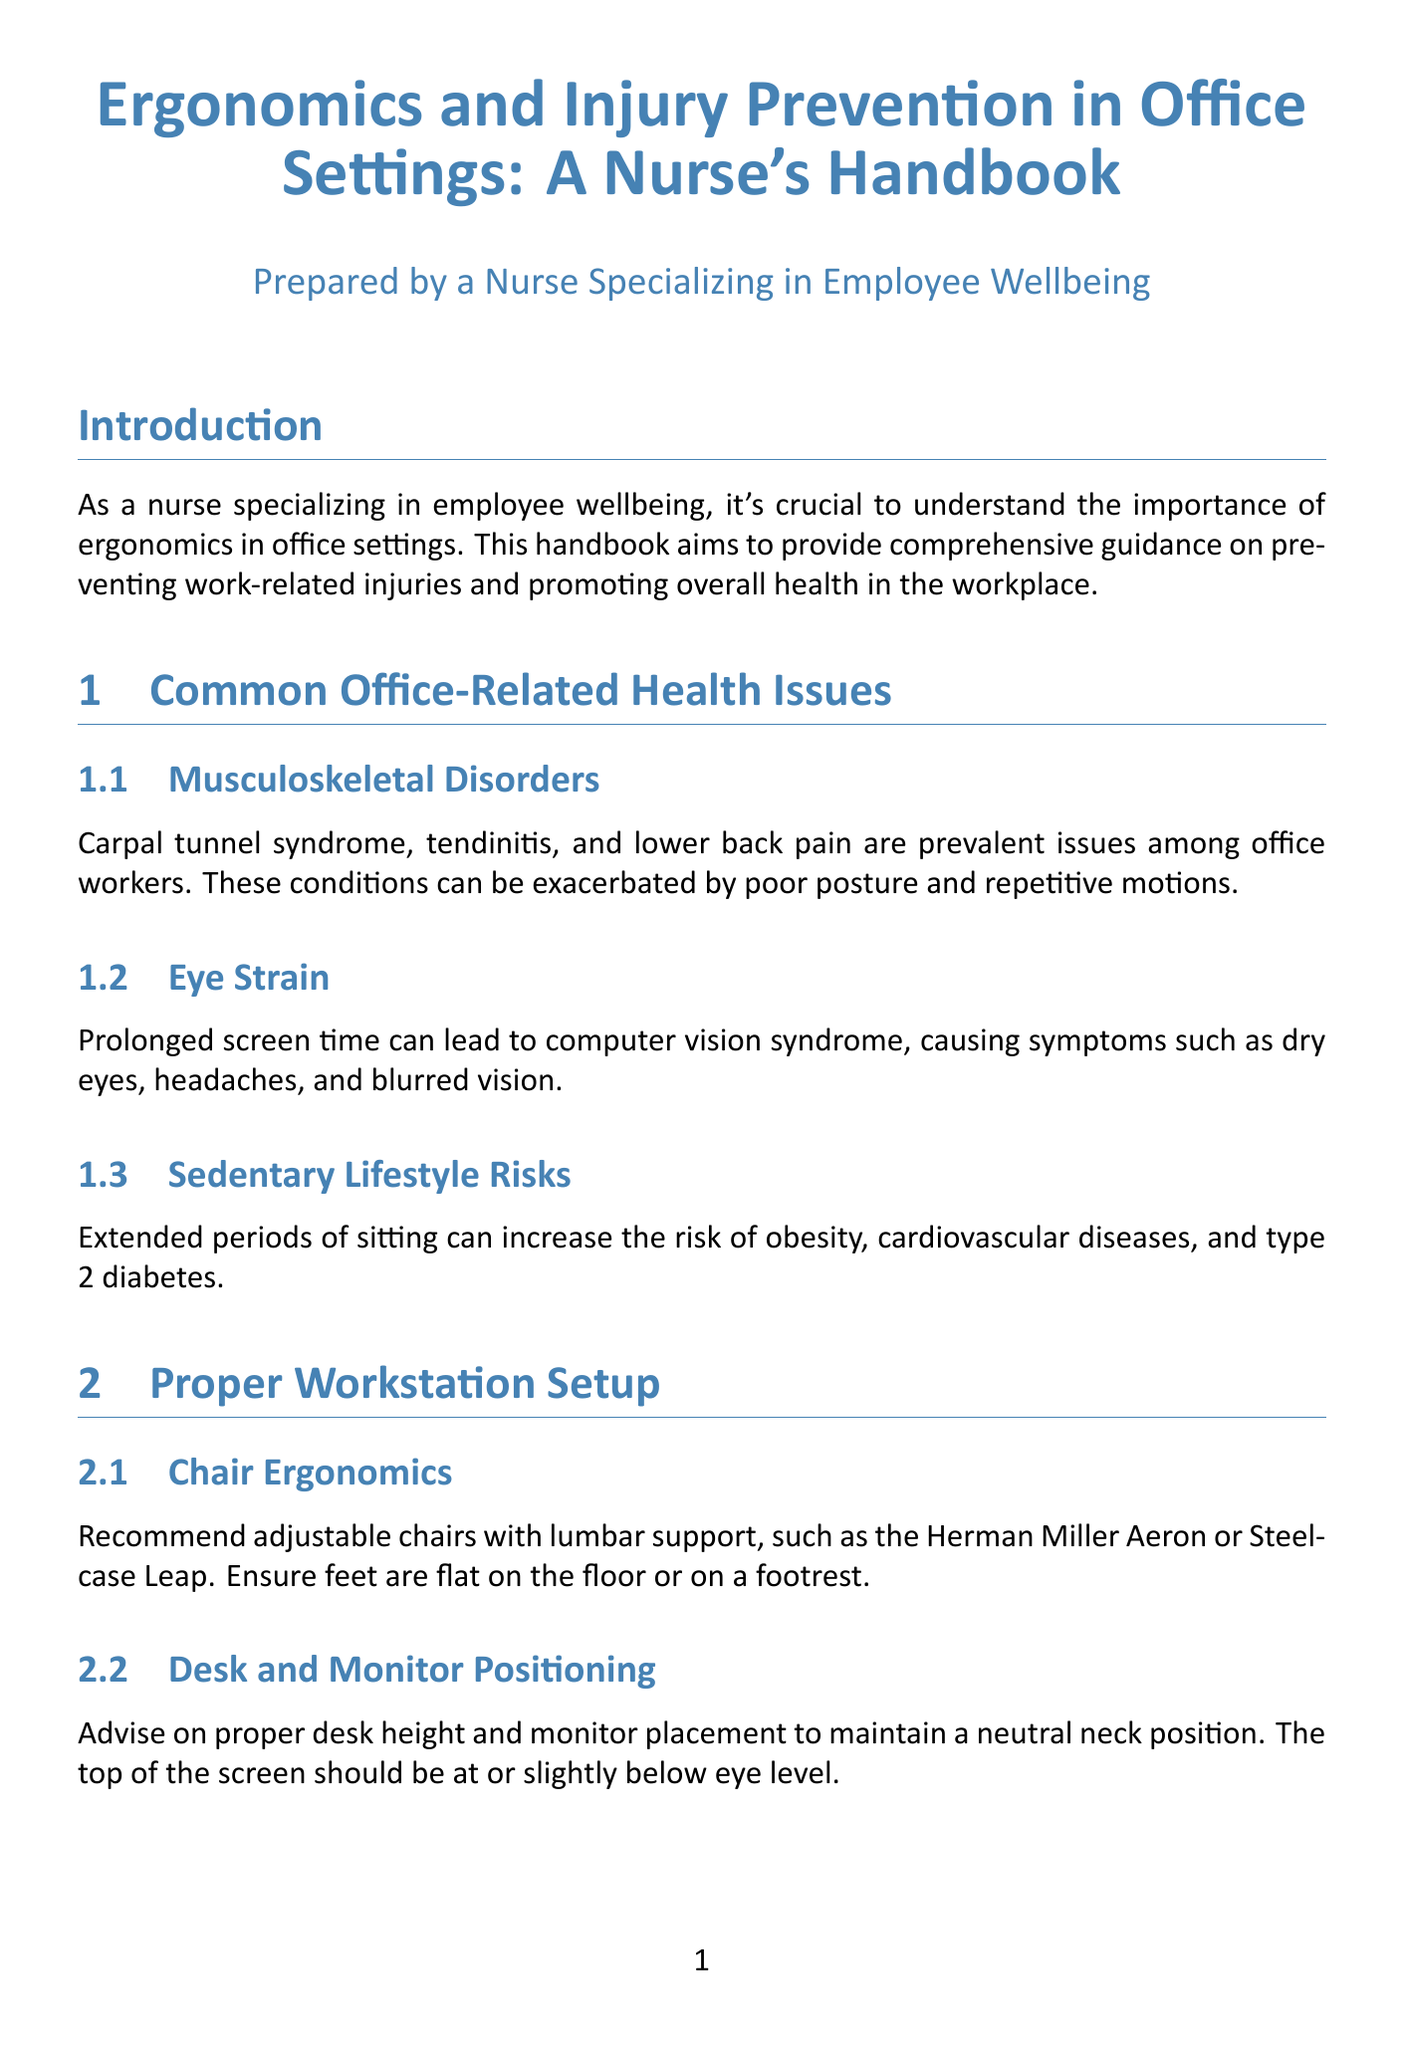What are common office-related health issues? The document lists common office-related health issues including musculoskeletal disorders, eye strain, and sedentary lifestyle risks.
Answer: Musculoskeletal disorders, eye strain, sedentary lifestyle risks What is the recommended chair for ergonomic support? The text recommends adjustable chairs with lumbar support, specifically naming the Herman Miller Aeron or Steelcase Leap.
Answer: Herman Miller Aeron, Steelcase Leap What does the document suggest for managing work-related stress? It provides techniques such as mindfulness exercises and recommends apps like Headspace or Calm.
Answer: Mindfulness exercises, Headspace, Calm What is one example of an active sitting option mentioned? The document introduces the concept of using stability balls or active sitting chairs such as the Varier Move Tilting Saddle Stool.
Answer: Varier Move Tilting Saddle Stool What are two suggested tools for ergonomic assessments? The document outlines the use of tools like the OSHA Computer Workstation eTool for conducting assessments.
Answer: OSHA Computer Workstation eTool How does proper lighting help in an office environment? The document discusses the importance of proper lighting to reduce eye strain, recommending adjustable desk lamps like the BenQ e-Reading LED Desk Lamp.
Answer: Reduce eye strain What is an effect of prolonged screen time? The document identifies symptoms such as dry eyes, headaches, and blurred vision as effects of prolonged screen time.
Answer: Dry eyes, headaches, blurred vision What should be the top of the monitor considered at eye level? The document advises that the top of the monitor should be at or slightly below eye level to maintain neck neutrality.
Answer: At or slightly below eye level What is the ultimate goal of implementing strategies in this handbook? The goal is to promote ergonomics and injury prevention in office settings to improve employee wellbeing and productivity.
Answer: Improved employee wellbeing and productivity 